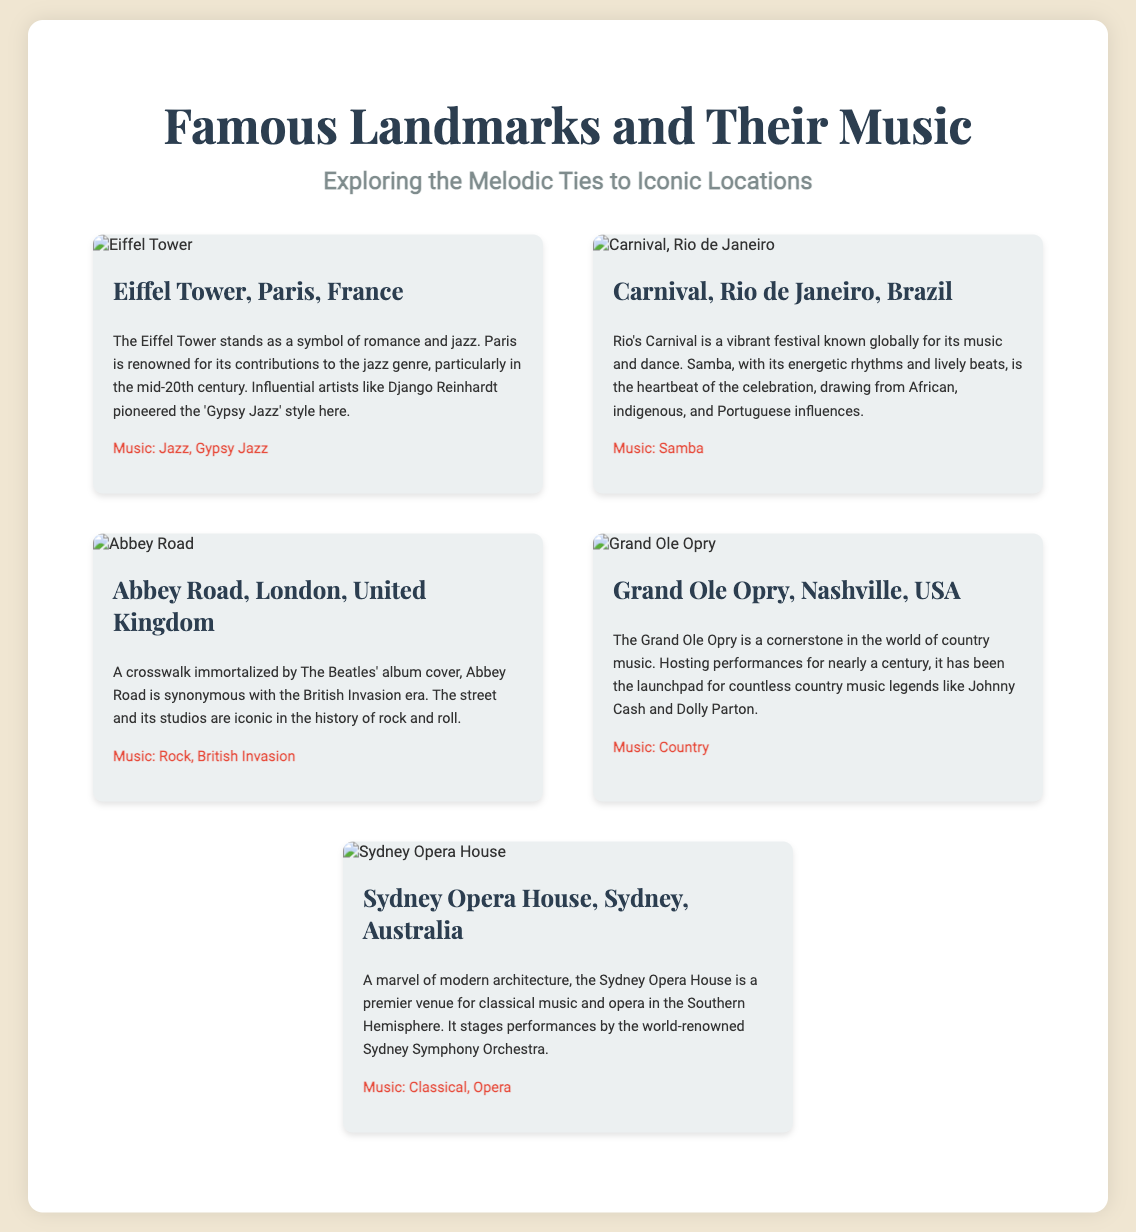What city is the Eiffel Tower located in? The document states that the Eiffel Tower is in Paris, France.
Answer: Paris What is the primary music genre associated with Rio's Carnival? The description indicates that Samba is the music associated with Carnival in Rio de Janeiro.
Answer: Samba Which landmark is associated with The Beatles? The document connects Abbey Road with The Beatles, particularly mentioning its famous album cover.
Answer: Abbey Road What type of music is the Grand Ole Opry known for? The text mentions that the Grand Ole Opry is a cornerstone in the world of country music.
Answer: Country Who are two country music legends mentioned in relation to the Grand Ole Opry? The description highlights Johnny Cash and Dolly Parton as legends associated with the Grand Ole Opry.
Answer: Johnny Cash and Dolly Parton Which landmark is a symbol of romance and jazz? The document identifies the Eiffel Tower as a symbol of romance and jazz music.
Answer: Eiffel Tower What musical style did Django Reinhardt pioneer in Paris? The text refers to Gypsy Jazz as the style associated with Django Reinhardt in Paris.
Answer: Gypsy Jazz What is the Sydney Opera House primarily known for? According to the document, the Sydney Opera House is known as a venue for classical music and opera.
Answer: Classical music and opera What festival is Rio de Janeiro famous for? The document describes the Carnival as a vibrant festival known globally in Rio de Janeiro.
Answer: Carnival 